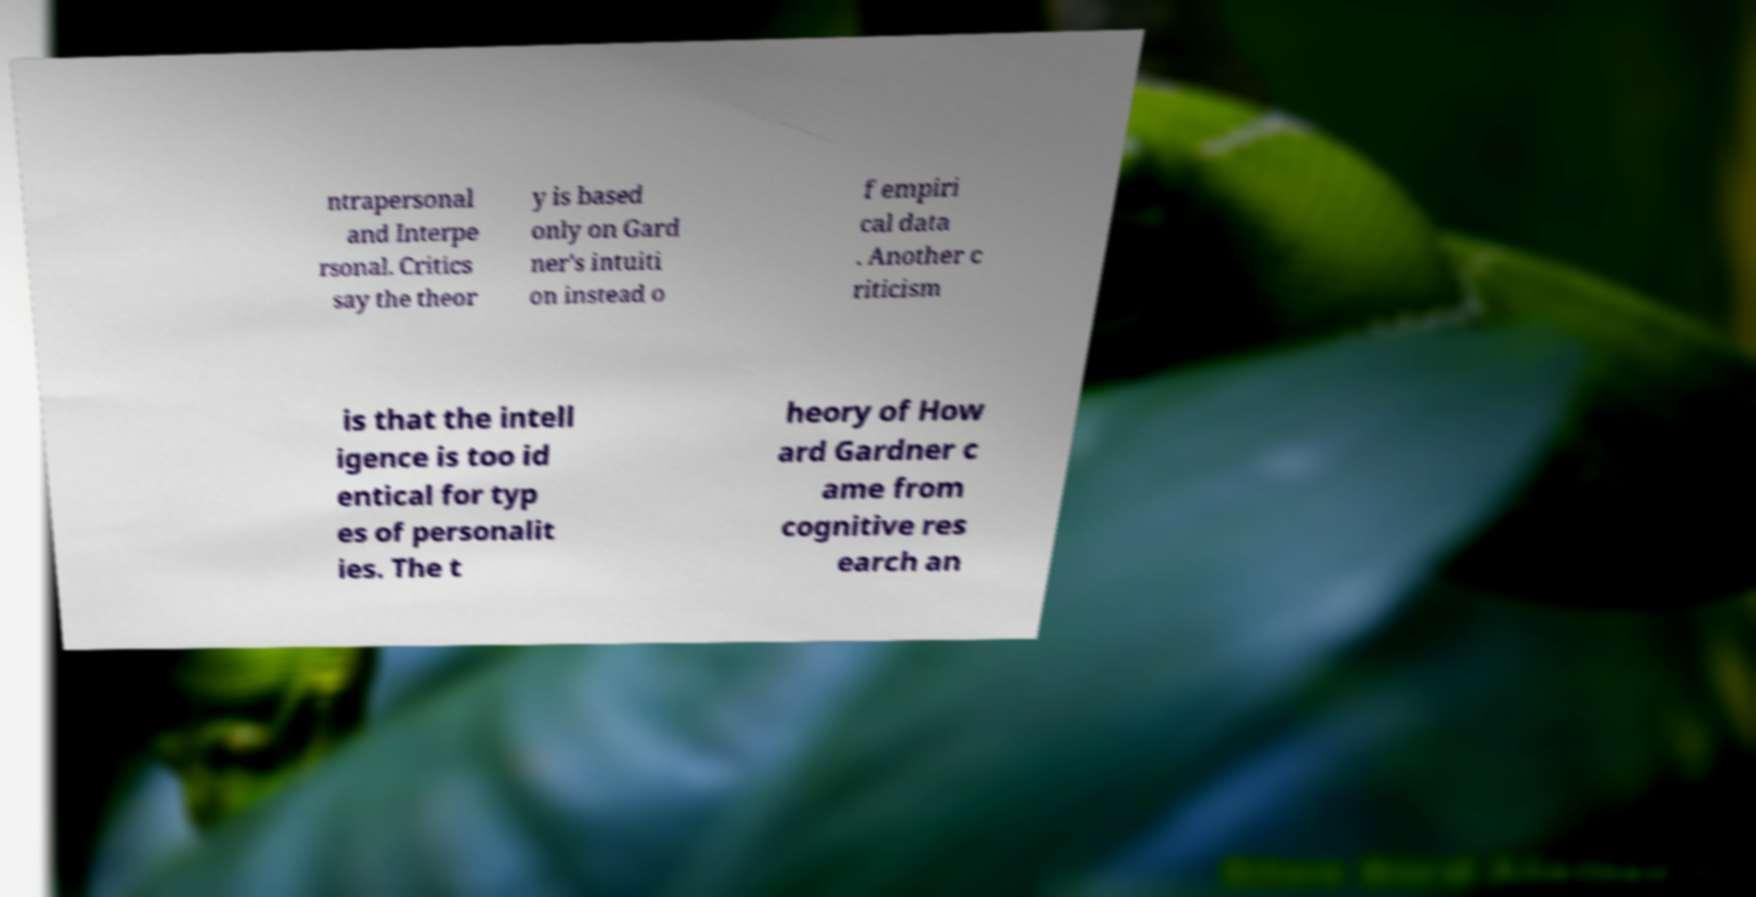I need the written content from this picture converted into text. Can you do that? ntrapersonal and Interpe rsonal. Critics say the theor y is based only on Gard ner's intuiti on instead o f empiri cal data . Another c riticism is that the intell igence is too id entical for typ es of personalit ies. The t heory of How ard Gardner c ame from cognitive res earch an 